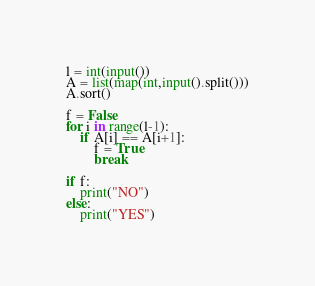<code> <loc_0><loc_0><loc_500><loc_500><_Python_>l = int(input())
A = list(map(int,input().split()))
A.sort()

f = False
for i in range(l-1):
    if A[i] == A[i+1]:
        f = True
        break

if f:
    print("NO")
else:
    print("YES")</code> 